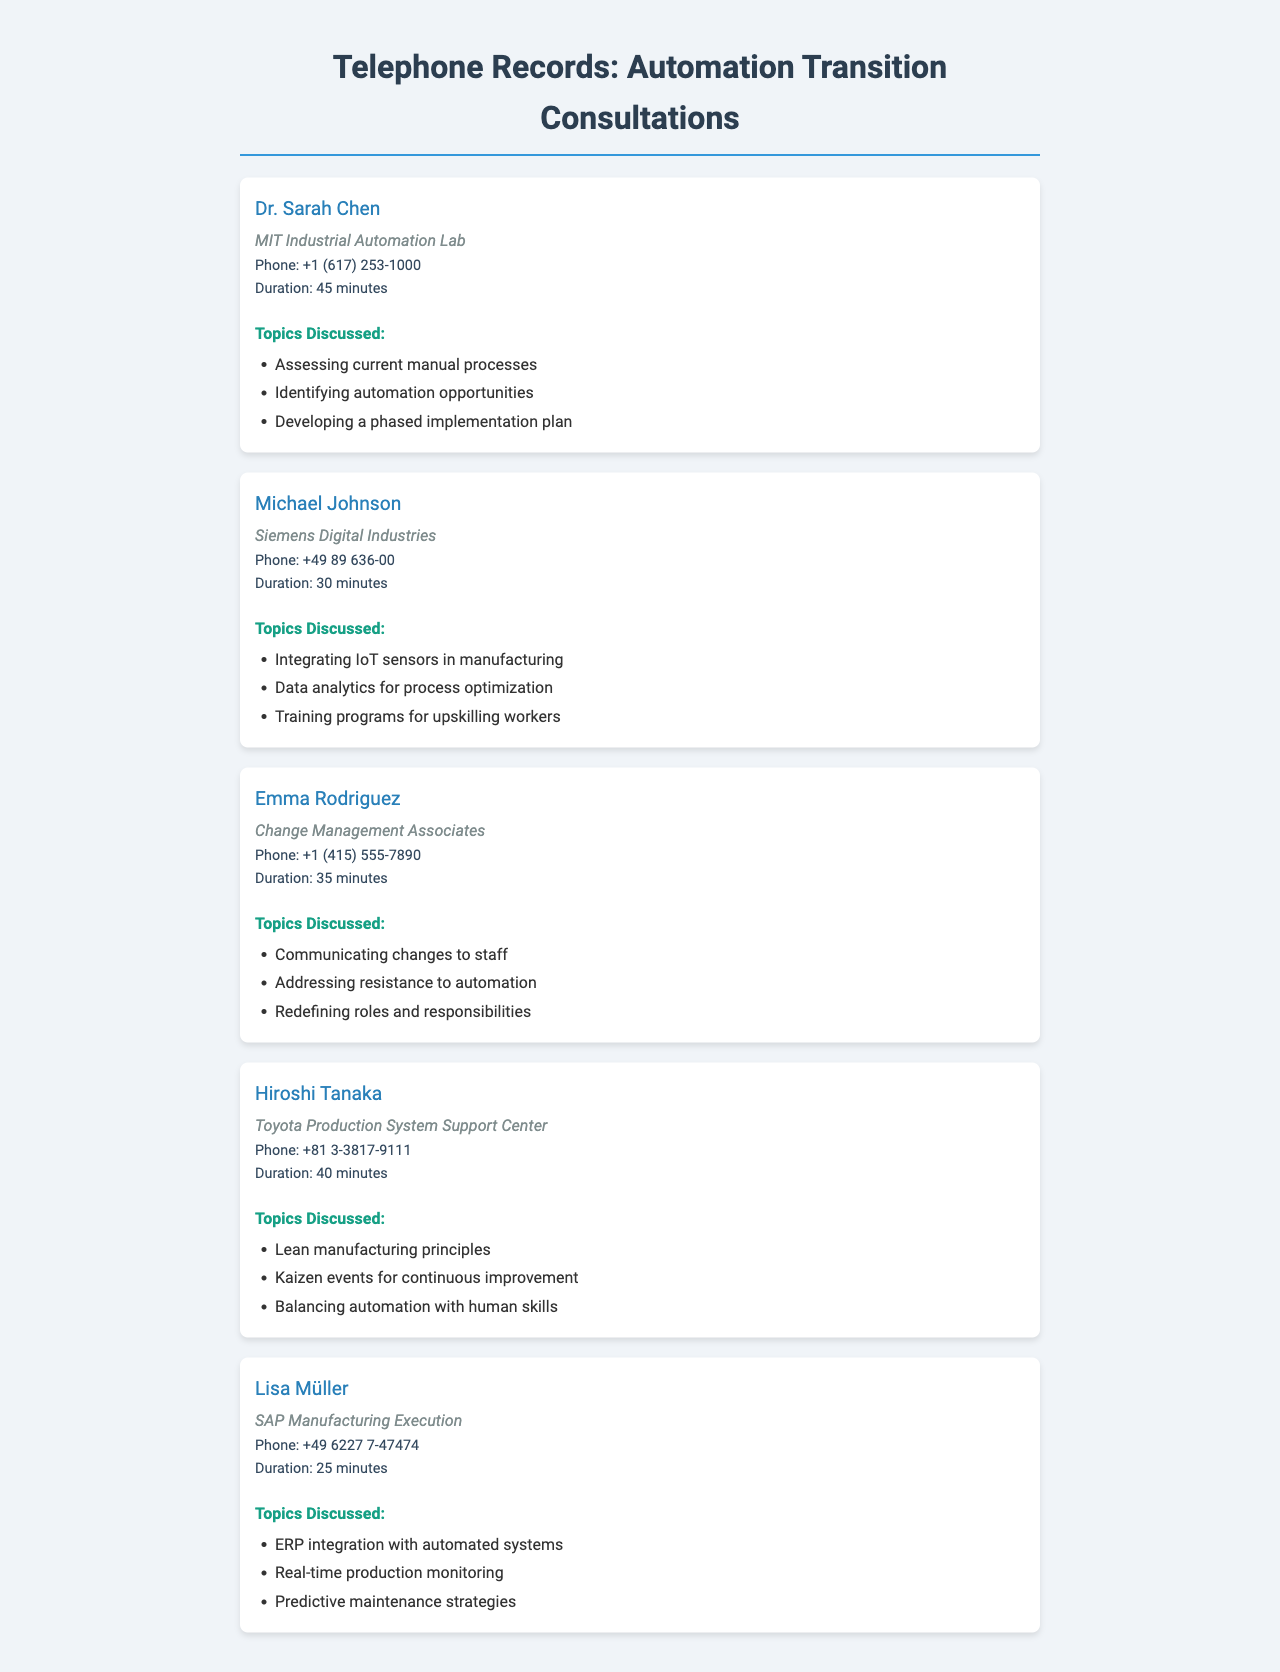What is the name of the first contact? The first contact listed in the telephone records is Dr. Sarah Chen.
Answer: Dr. Sarah Chen How long was the call with Michael Johnson? The call duration with Michael Johnson is mentioned as 30 minutes.
Answer: 30 minutes Which organization does Lisa Müller represent? Lisa Müller is affiliated with SAP Manufacturing Execution, as noted in the document.
Answer: SAP Manufacturing Execution What topic did Hiroshi Tanaka discuss related to continuous improvement? Hiroshi Tanaka discussed Kaizen events for continuous improvement during the call.
Answer: Kaizen events for continuous improvement Who is associated with the integration of IoT sensors? The integration of IoT sensors in manufacturing was discussed by Michael Johnson.
Answer: Michael Johnson How many minutes was the call with Emma Rodriguez? The call duration with Emma Rodriguez is indicated as 35 minutes.
Answer: 35 minutes What organization does Dr. Sarah Chen work for? Dr. Sarah Chen is part of the MIT Industrial Automation Lab, as stated in the records.
Answer: MIT Industrial Automation Lab What is the phone number for Hiroshi Tanaka? The phone number listed for Hiroshi Tanaka is +81 3-3817-9111.
Answer: +81 3-3817-9111 What specific topic did Lisa Müller discuss regarding production? Lisa Müller talked about real-time production monitoring as part of her call topics.
Answer: Real-time production monitoring 